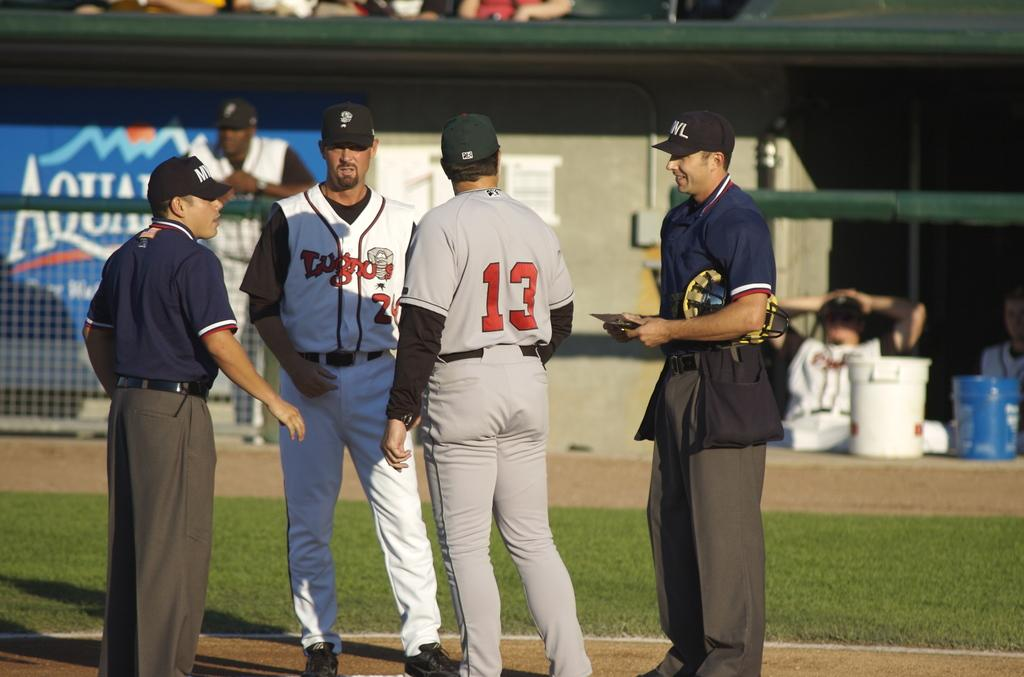<image>
Render a clear and concise summary of the photo. Four men on a baseball field are talking in front of Aquafina sign. 